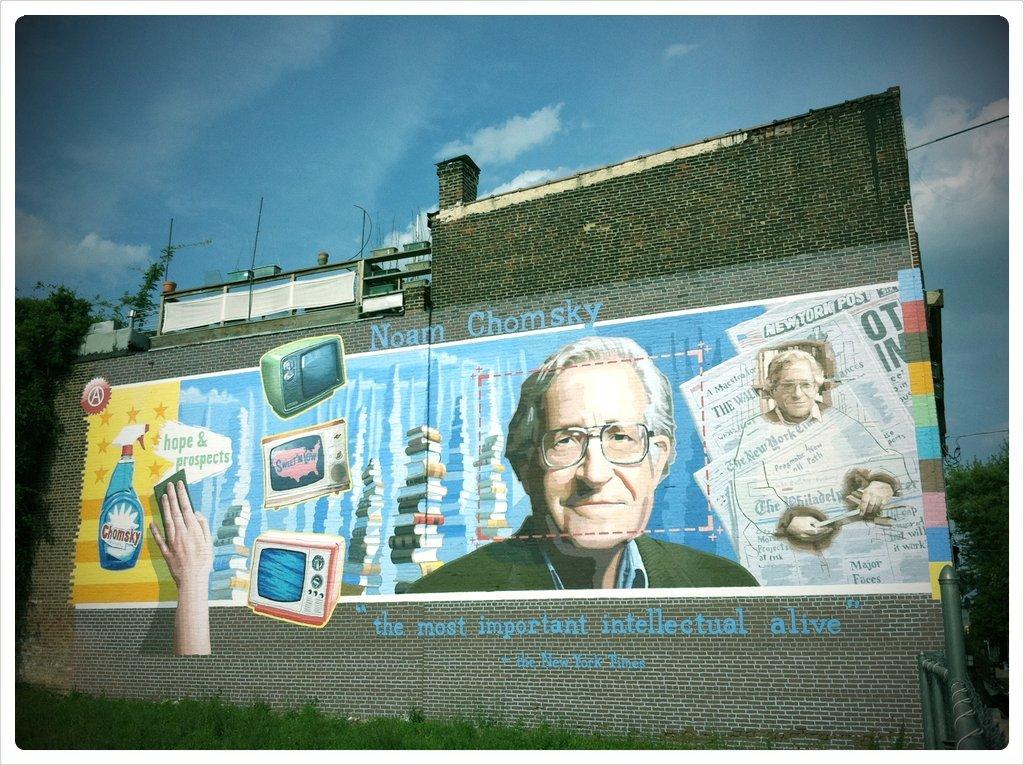What is this man's name?
Offer a terse response. Noam chomsky. What is he known as?
Offer a terse response. The most important intellectual alive. 